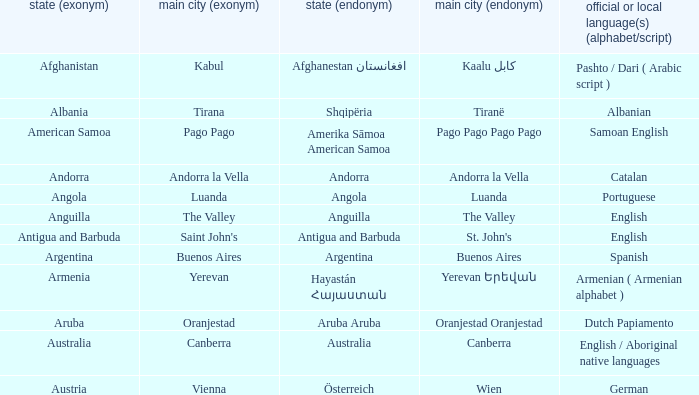What is the local name given to the city of Canberra? Canberra. 